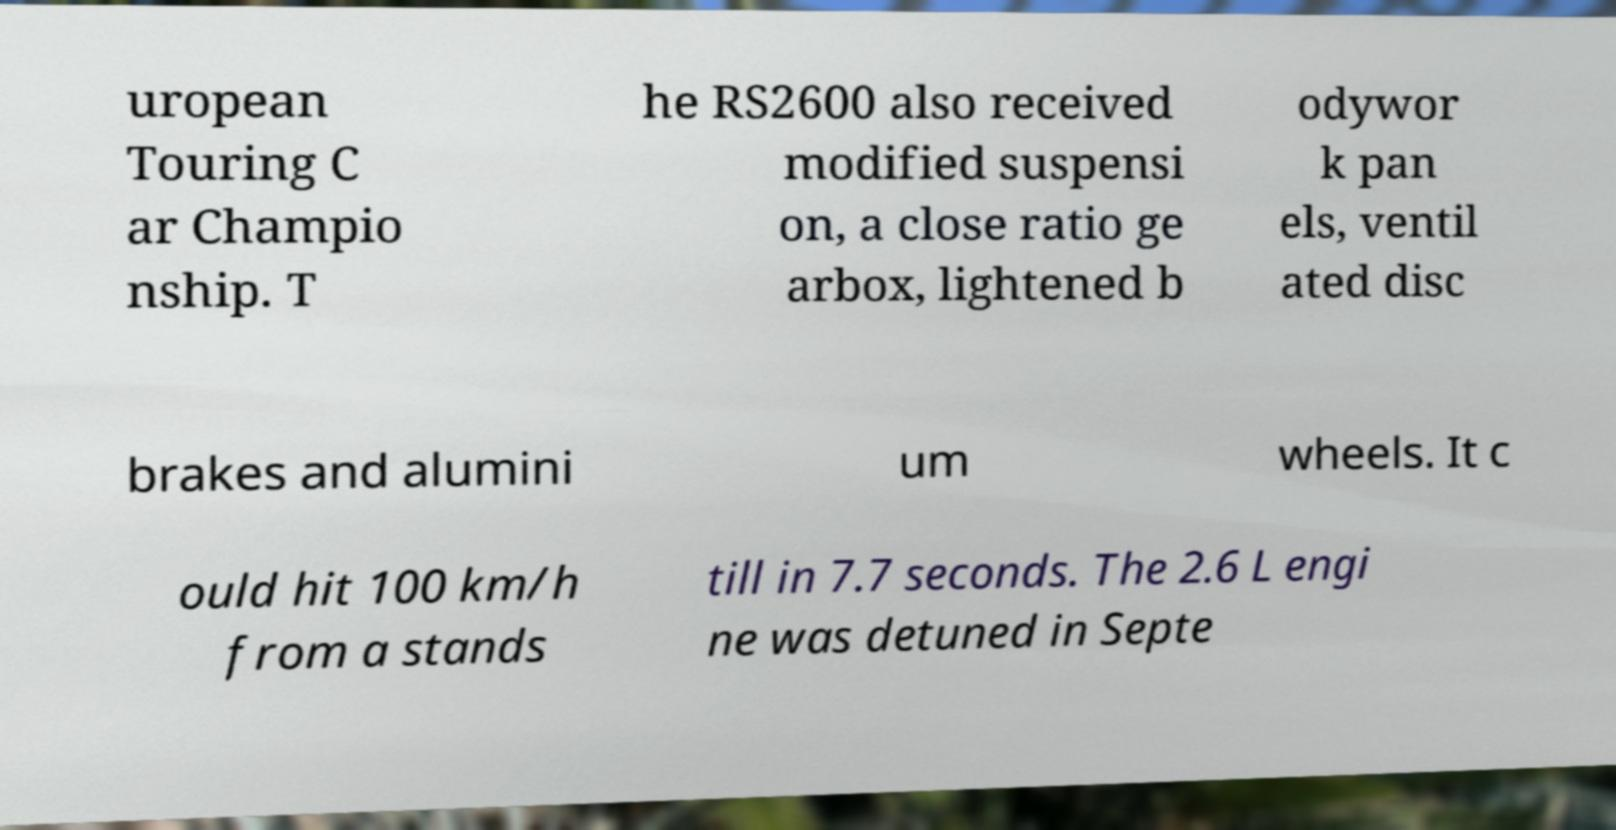Can you accurately transcribe the text from the provided image for me? uropean Touring C ar Champio nship. T he RS2600 also received modified suspensi on, a close ratio ge arbox, lightened b odywor k pan els, ventil ated disc brakes and alumini um wheels. It c ould hit 100 km/h from a stands till in 7.7 seconds. The 2.6 L engi ne was detuned in Septe 